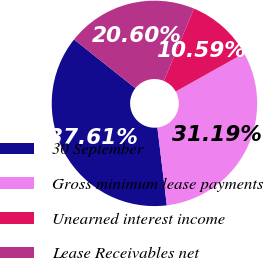Convert chart. <chart><loc_0><loc_0><loc_500><loc_500><pie_chart><fcel>30 September<fcel>Gross minimum lease payments<fcel>Unearned interest income<fcel>Lease Receivables net<nl><fcel>37.61%<fcel>31.19%<fcel>10.59%<fcel>20.6%<nl></chart> 